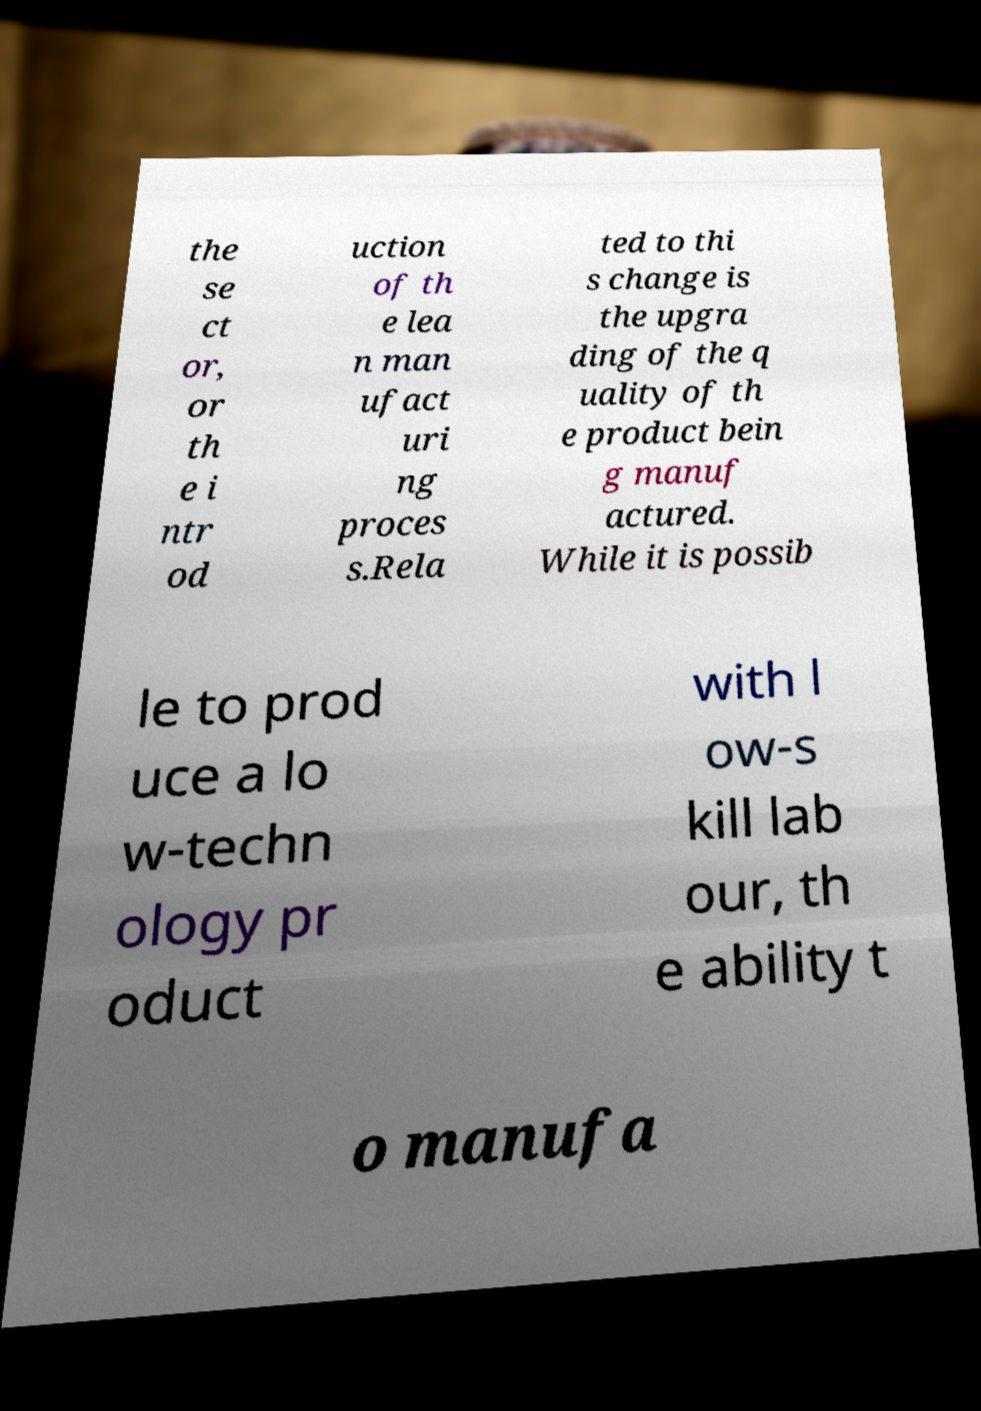For documentation purposes, I need the text within this image transcribed. Could you provide that? the se ct or, or th e i ntr od uction of th e lea n man ufact uri ng proces s.Rela ted to thi s change is the upgra ding of the q uality of th e product bein g manuf actured. While it is possib le to prod uce a lo w-techn ology pr oduct with l ow-s kill lab our, th e ability t o manufa 